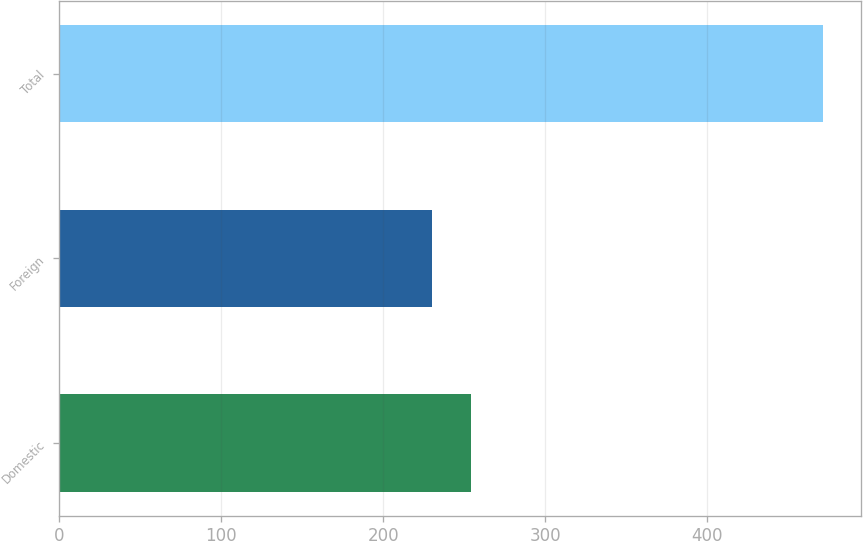Convert chart to OTSL. <chart><loc_0><loc_0><loc_500><loc_500><bar_chart><fcel>Domestic<fcel>Foreign<fcel>Total<nl><fcel>254.33<fcel>230.2<fcel>471.5<nl></chart> 